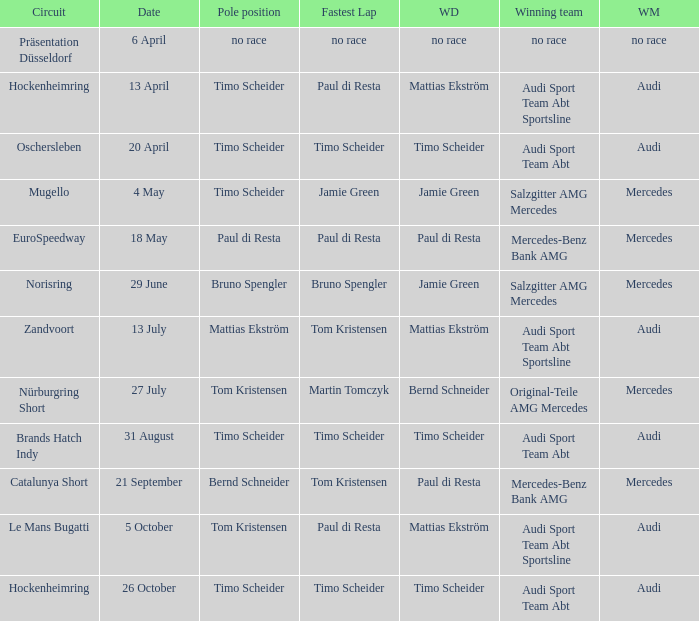What is the fastest lap of the Oschersleben circuit with Audi Sport Team ABT as the winning team? Timo Scheider. 